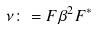<formula> <loc_0><loc_0><loc_500><loc_500>\nu \colon = F \beta ^ { 2 } F ^ { * }</formula> 